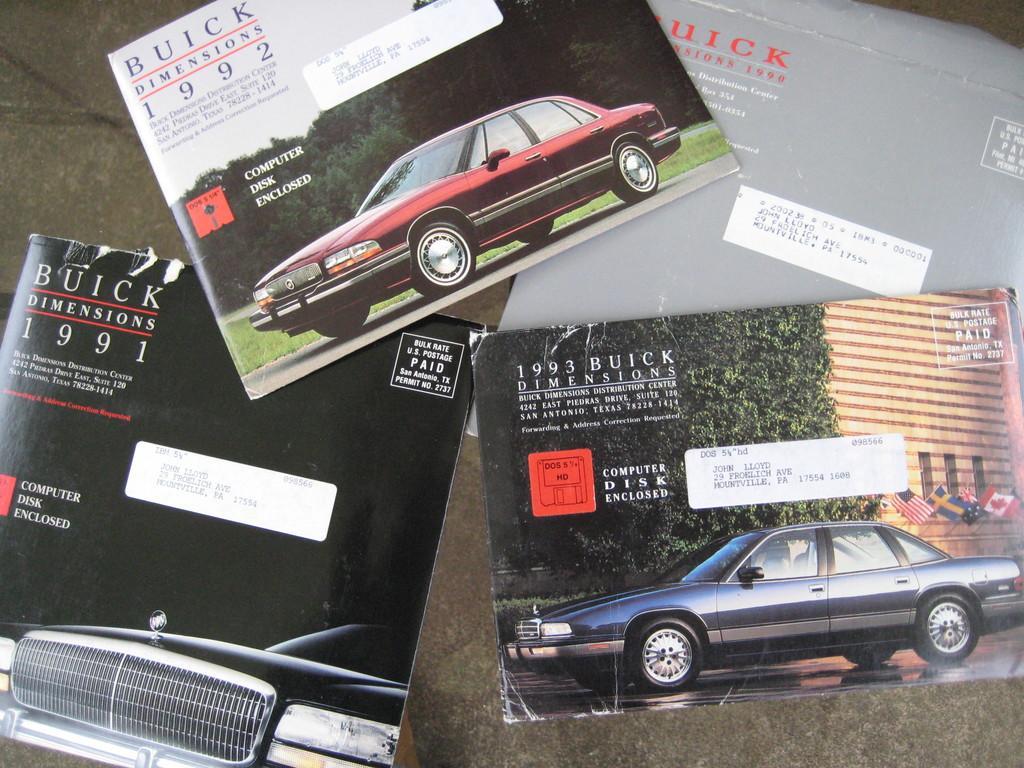Describe this image in one or two sentences. In the center of the image we can see books placed on the table. 